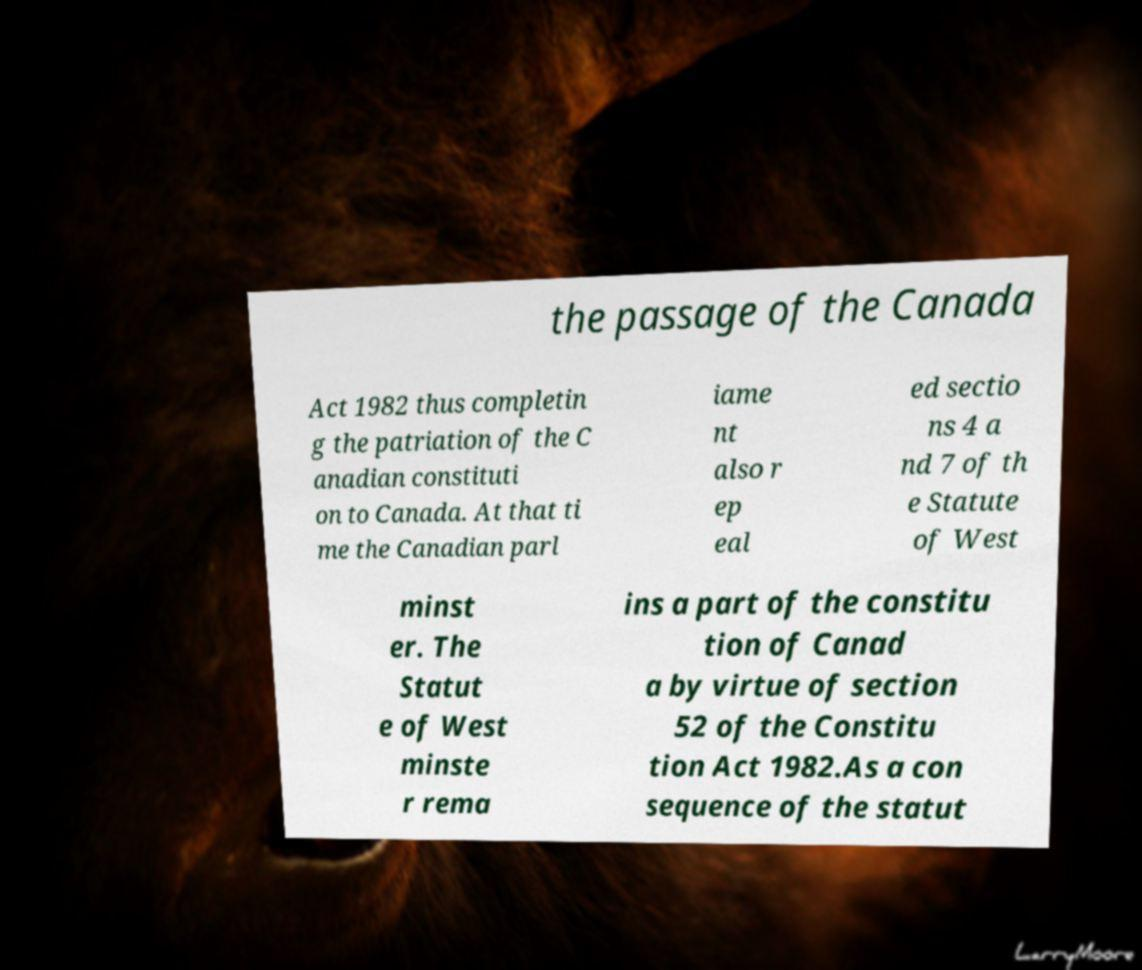Please read and relay the text visible in this image. What does it say? the passage of the Canada Act 1982 thus completin g the patriation of the C anadian constituti on to Canada. At that ti me the Canadian parl iame nt also r ep eal ed sectio ns 4 a nd 7 of th e Statute of West minst er. The Statut e of West minste r rema ins a part of the constitu tion of Canad a by virtue of section 52 of the Constitu tion Act 1982.As a con sequence of the statut 